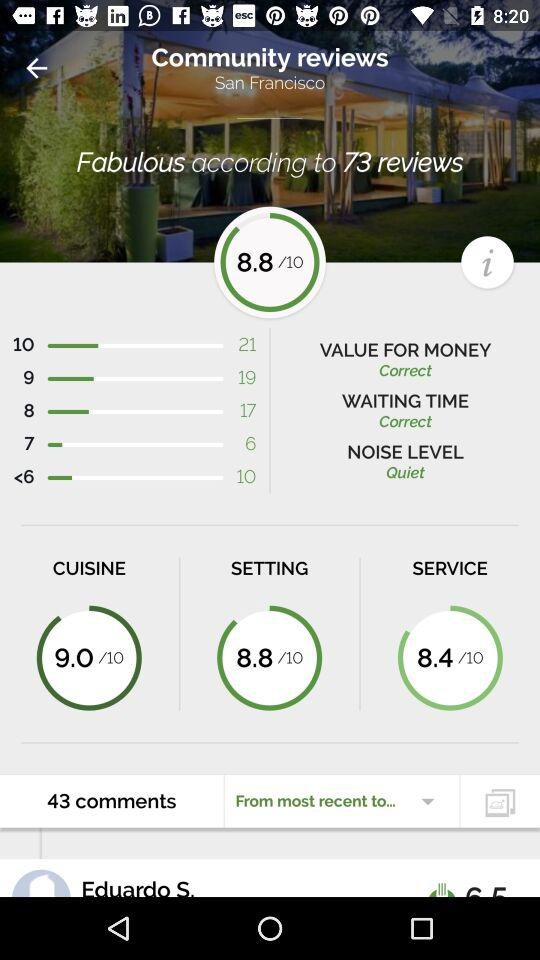What location is shown? The shown location is San Francisco. 